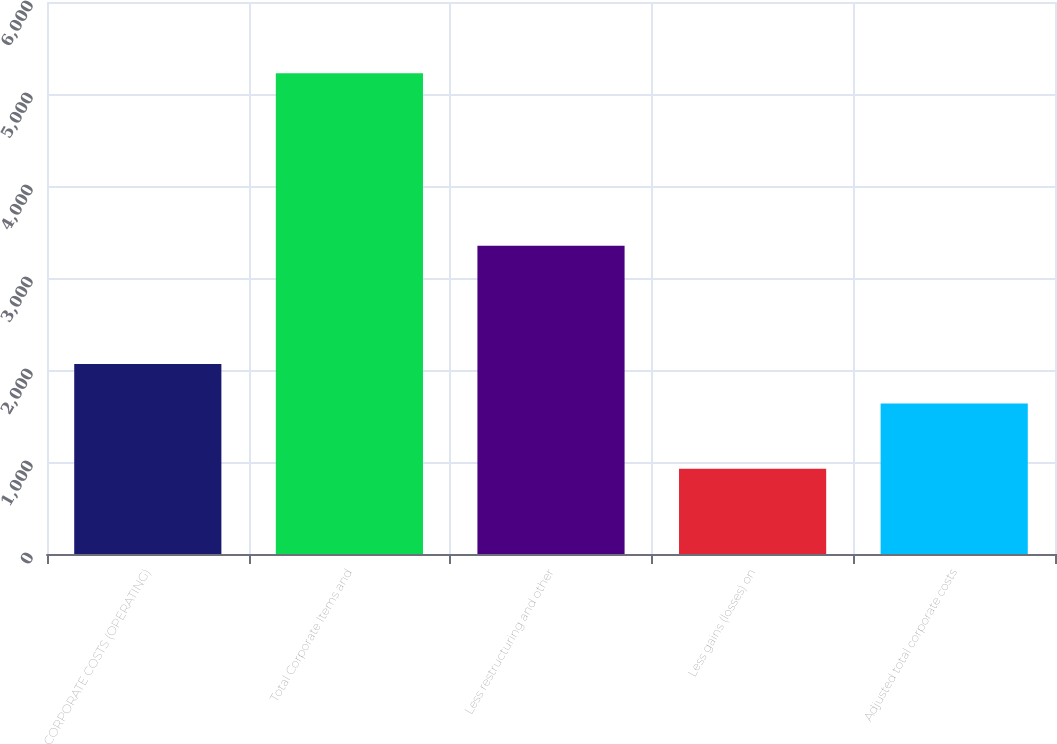<chart> <loc_0><loc_0><loc_500><loc_500><bar_chart><fcel>CORPORATE COSTS (OPERATING)<fcel>Total Corporate Items and<fcel>Less restructuring and other<fcel>Less gains (losses) on<fcel>Adjusted total corporate costs<nl><fcel>2065.9<fcel>5225<fcel>3351<fcel>926<fcel>1636<nl></chart> 